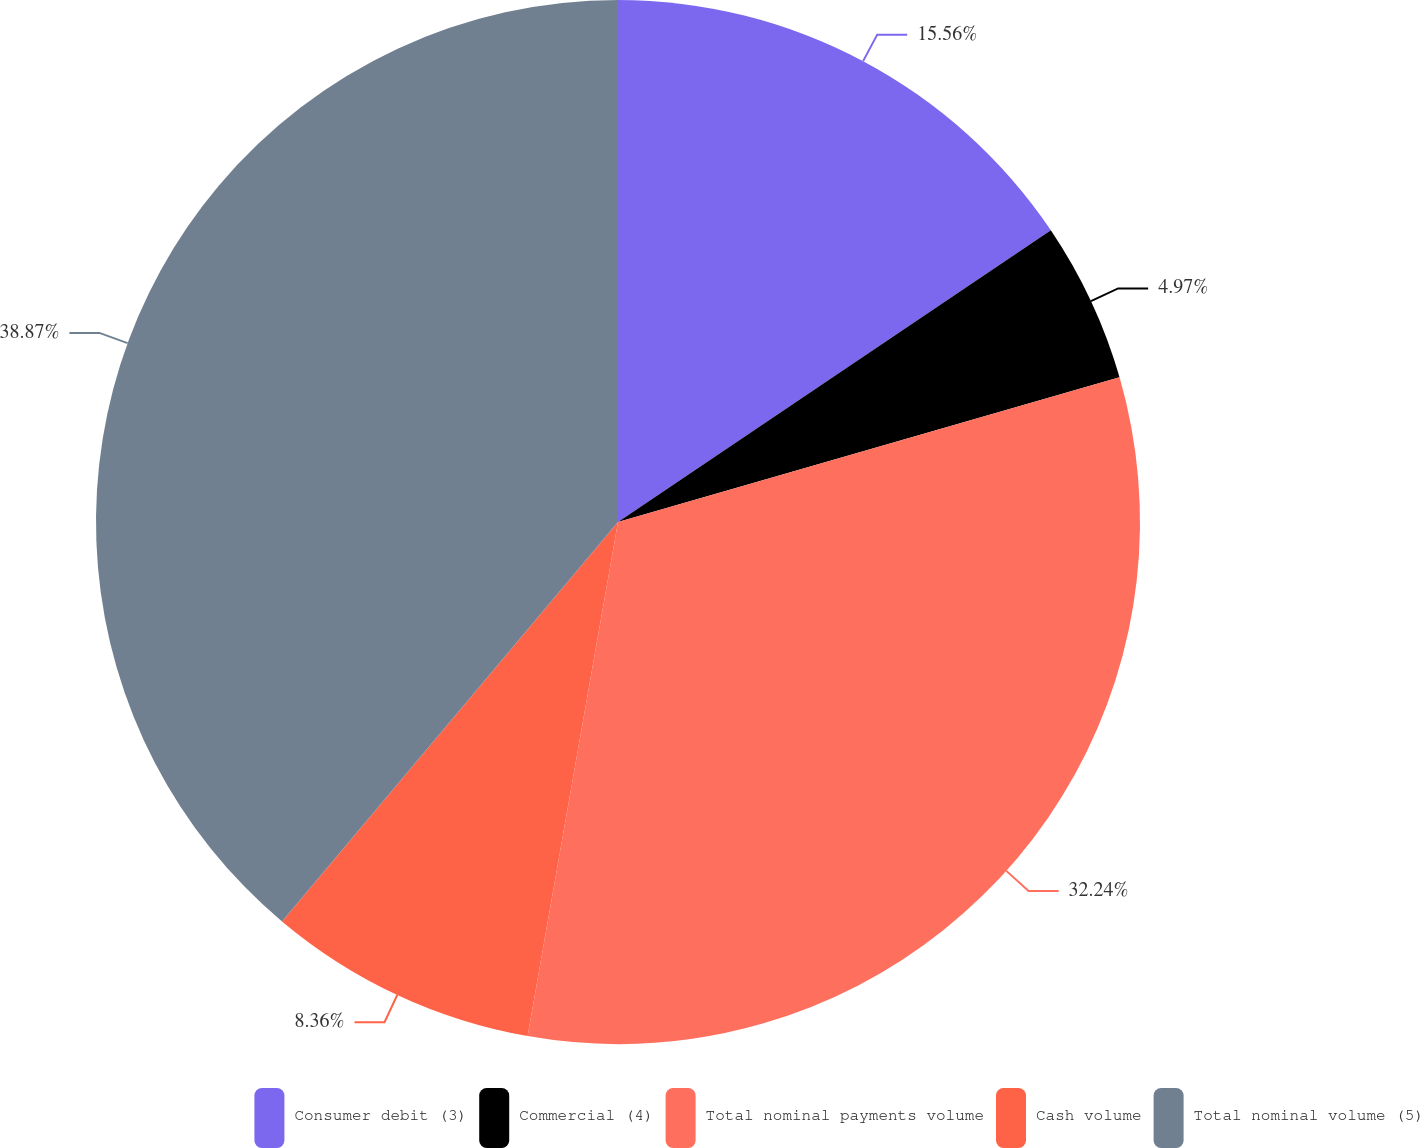Convert chart to OTSL. <chart><loc_0><loc_0><loc_500><loc_500><pie_chart><fcel>Consumer debit (3)<fcel>Commercial (4)<fcel>Total nominal payments volume<fcel>Cash volume<fcel>Total nominal volume (5)<nl><fcel>15.56%<fcel>4.97%<fcel>32.24%<fcel>8.36%<fcel>38.87%<nl></chart> 